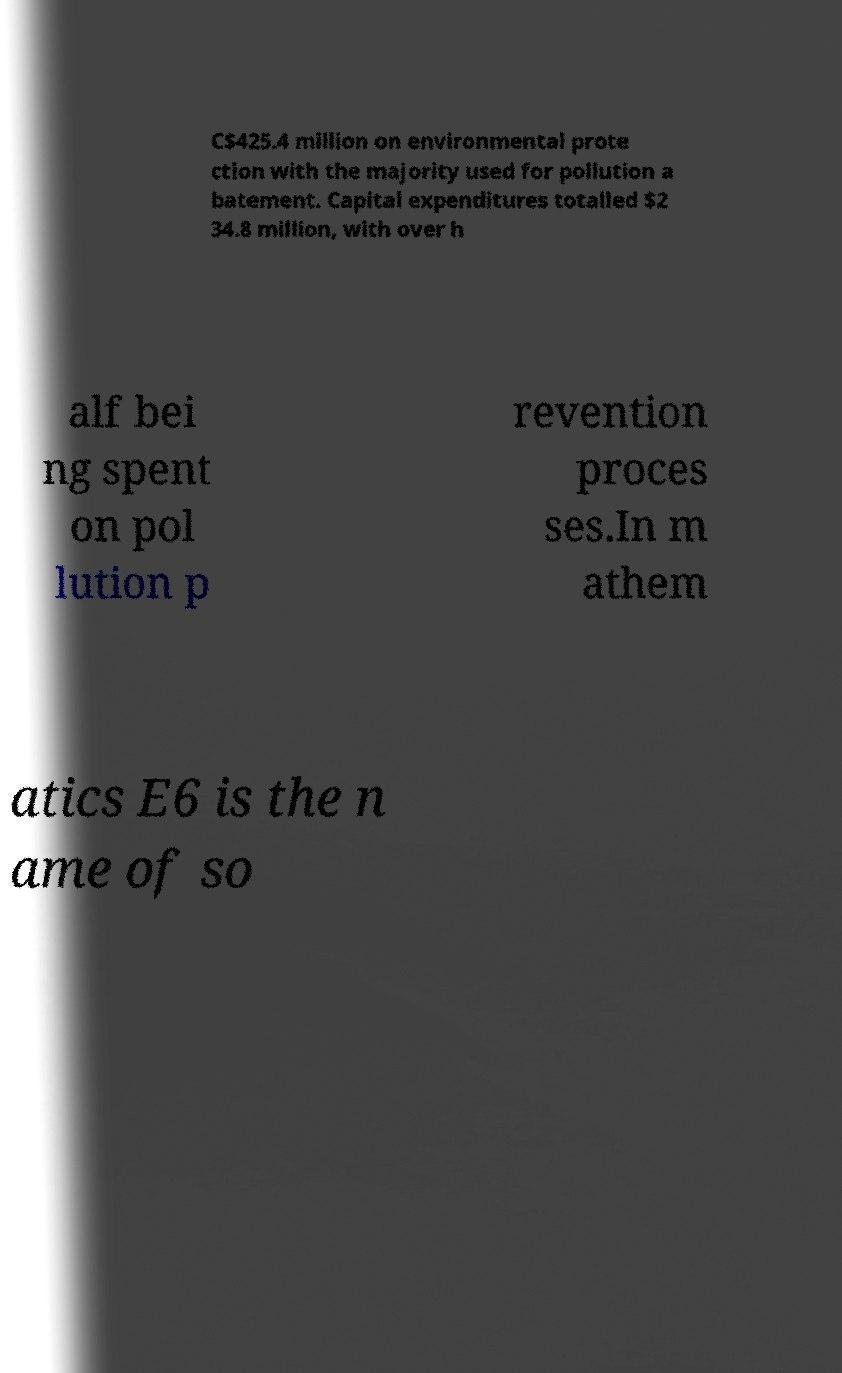Please identify and transcribe the text found in this image. C$425.4 million on environmental prote ction with the majority used for pollution a batement. Capital expenditures totalled $2 34.8 million, with over h alf bei ng spent on pol lution p revention proces ses.In m athem atics E6 is the n ame of so 